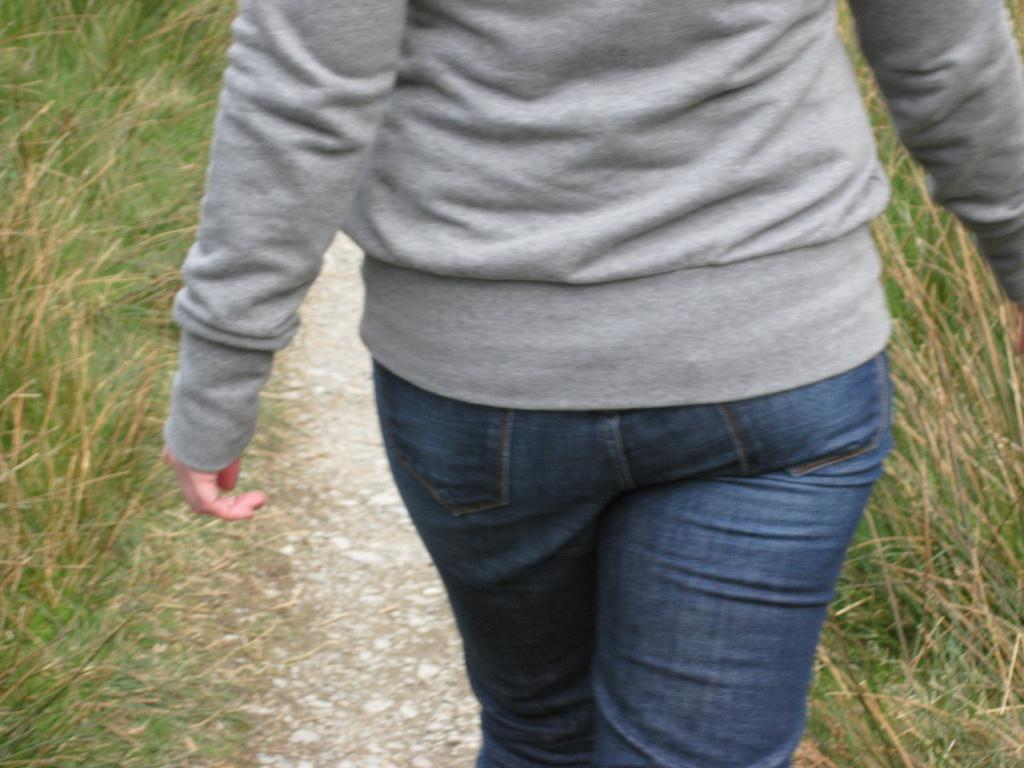Where was the image taken? The image was clicked outside. What is the main subject of the image? There is a person in the center of the image. What is the person wearing? The person is wearing a grey t-shirt. What is the person doing in the image? The person is walking on the ground. What type of vegetation can be seen on both sides of the person? There is grass on both sides of the person. What type of stem can be seen in the person's hand in the image? There is no stem present in the person's hand in the image. What type of food is the person eating in the image? The image does not show the person eating any food. 